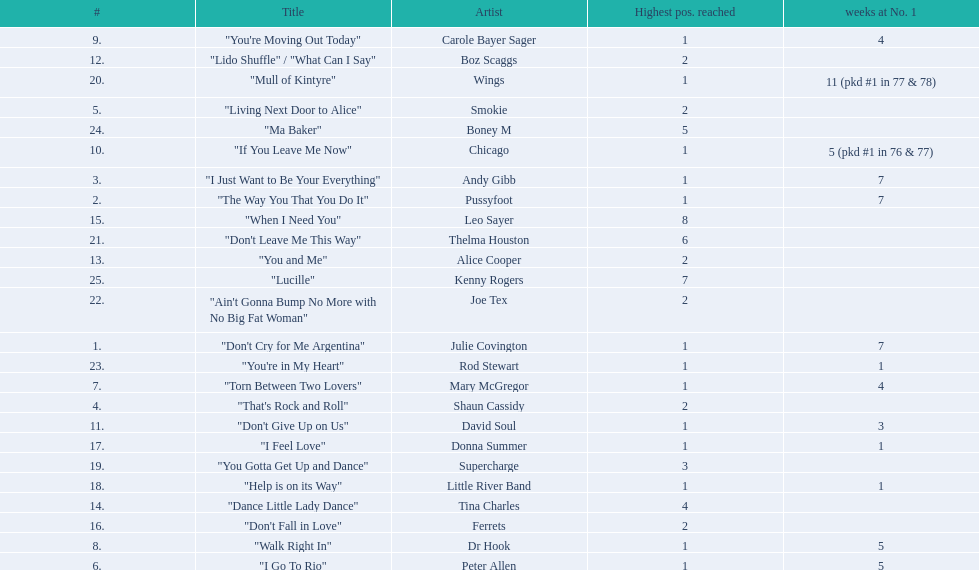Which song stayed at no.1 for the most amount of weeks. "Mull of Kintyre". 